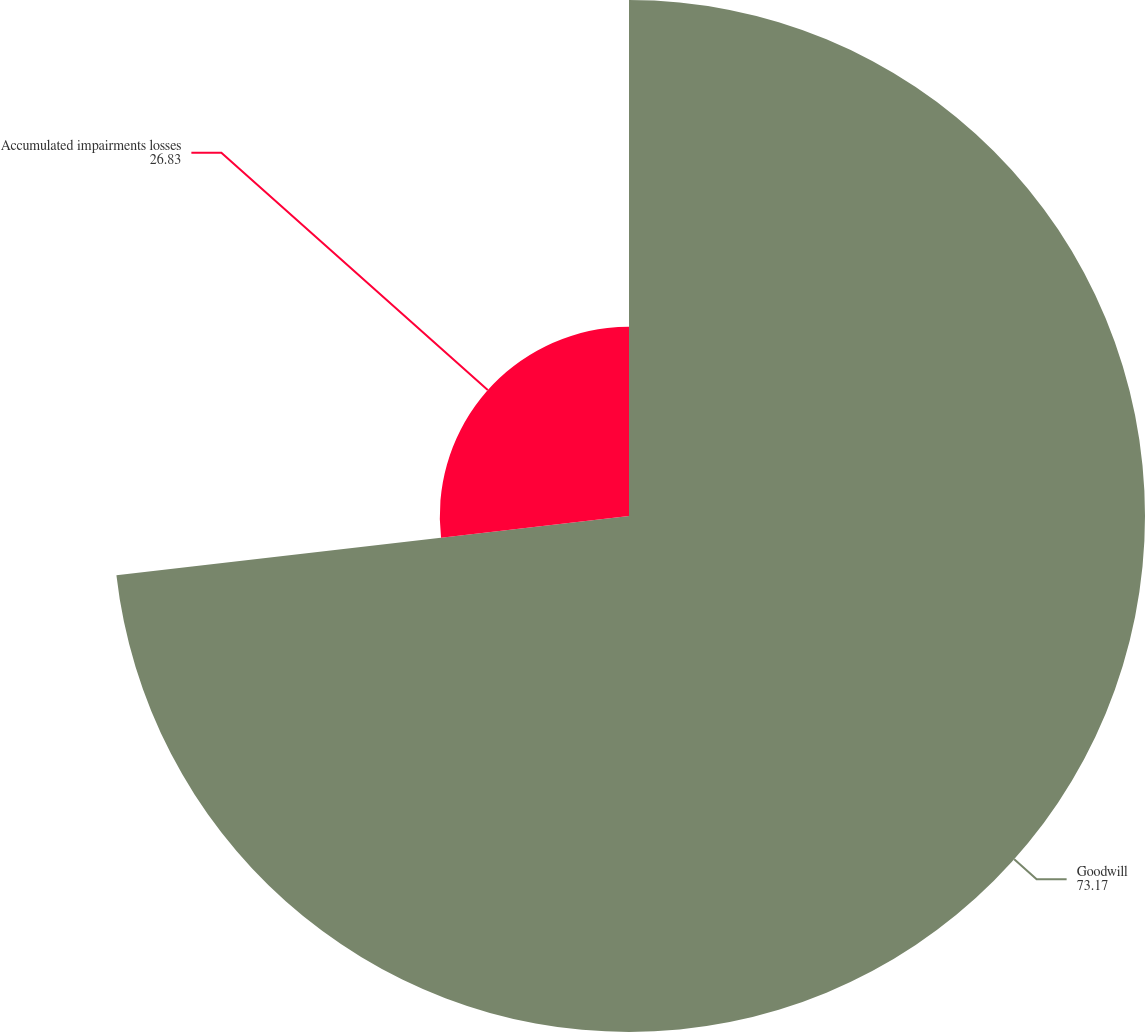Convert chart to OTSL. <chart><loc_0><loc_0><loc_500><loc_500><pie_chart><fcel>Goodwill<fcel>Accumulated impairments losses<nl><fcel>73.17%<fcel>26.83%<nl></chart> 